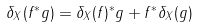Convert formula to latex. <formula><loc_0><loc_0><loc_500><loc_500>\delta _ { X } ( f ^ { * } g ) = \delta _ { X } ( f ) ^ { * } g + f ^ { * } \delta _ { X } ( g )</formula> 